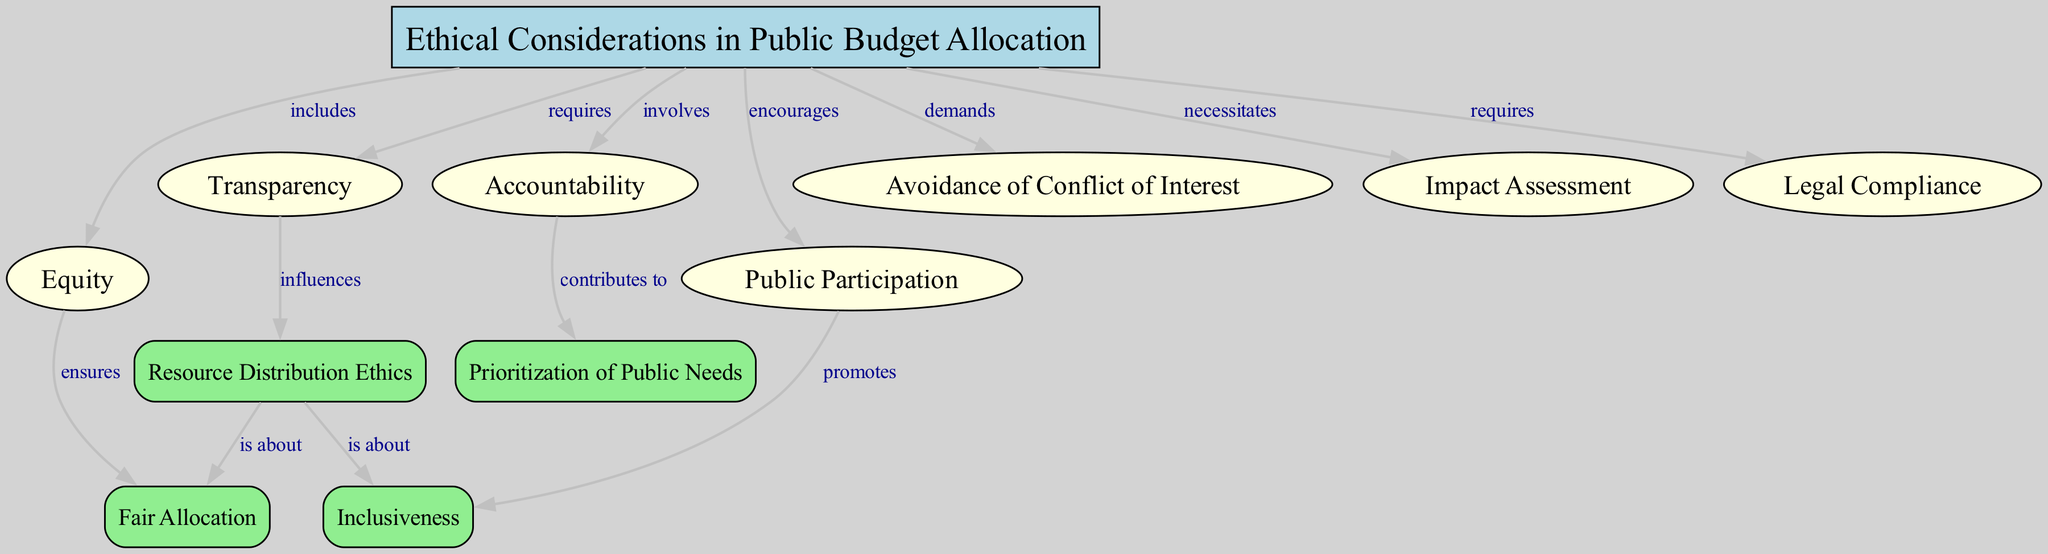What is the central theme of the diagram? The central theme of the diagram is represented by the main node labeled "Ethical Considerations in Public Budget Allocation". This node serves as the focal point from which all other ethical concepts radiate and relate to public budgeting practices.
Answer: Ethical Considerations in Public Budget Allocation How many total nodes are present in the diagram? By counting the nodes listed in the data, there are 12 unique nodes including the central theme and ethical concepts.
Answer: 12 Which ethical consideration promotes inclusiveness? The link from "Public Participation" to "Inclusiveness" indicates that public participation encourages inclusiveness within the budget allocation context.
Answer: Public Participation What does transparency influence according to the diagram? The diagram shows that "Transparency" influences "Resource Distribution Ethics", meaning that transparency is vital for ethical resource distribution in public budgeting.
Answer: Resource Distribution Ethics Which ethical consideration requires legal compliance? The node "Ethical Considerations in Public Budget Allocation" has a direct link to "Legal Compliance", identifying it as a requirement within the ethical budgeting context.
Answer: Legal Compliance How does equity ensure fair allocation? The link between "Equity" and "Fair Allocation" suggests that considering equity in budgeting processes is essential to ensuring that resources are allocated fairly to all demographics.
Answer: Fair Allocation In what way does accountability contribute to prioritization of public needs? The link from "Accountability" to "Prioritization of Public Needs" implies that maintaining accountability leads to better prioritization of essential public resources based on community needs.
Answer: Prioritization of Public Needs What is the relationship between resource distribution ethics and inclusiveness? The diagram suggests that "Resource Distribution Ethics" is about both "Fair Allocation" and "Inclusiveness", indicating that ethical resource distribution must focus on equitable and inclusive practices.
Answer: Fair Allocation, Inclusiveness What does avoidance of conflict of interest demand according to the diagram? The node "Avoidance of Conflict of Interest" is linked to the main node "Ethical Considerations in Public Budget Allocation", indicating that this consideration demands adherence to ethical principles in budgeting.
Answer: Ethical principles in budgeting 